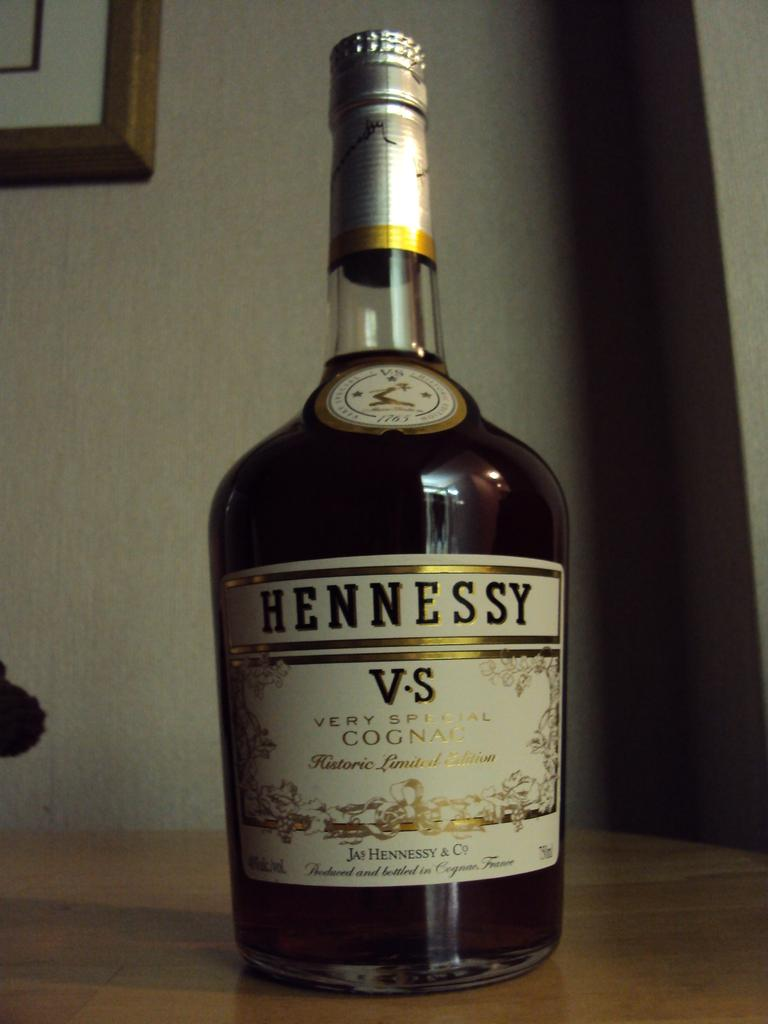Provide a one-sentence caption for the provided image. Large Hennessy bottle resting on a wooden table. 